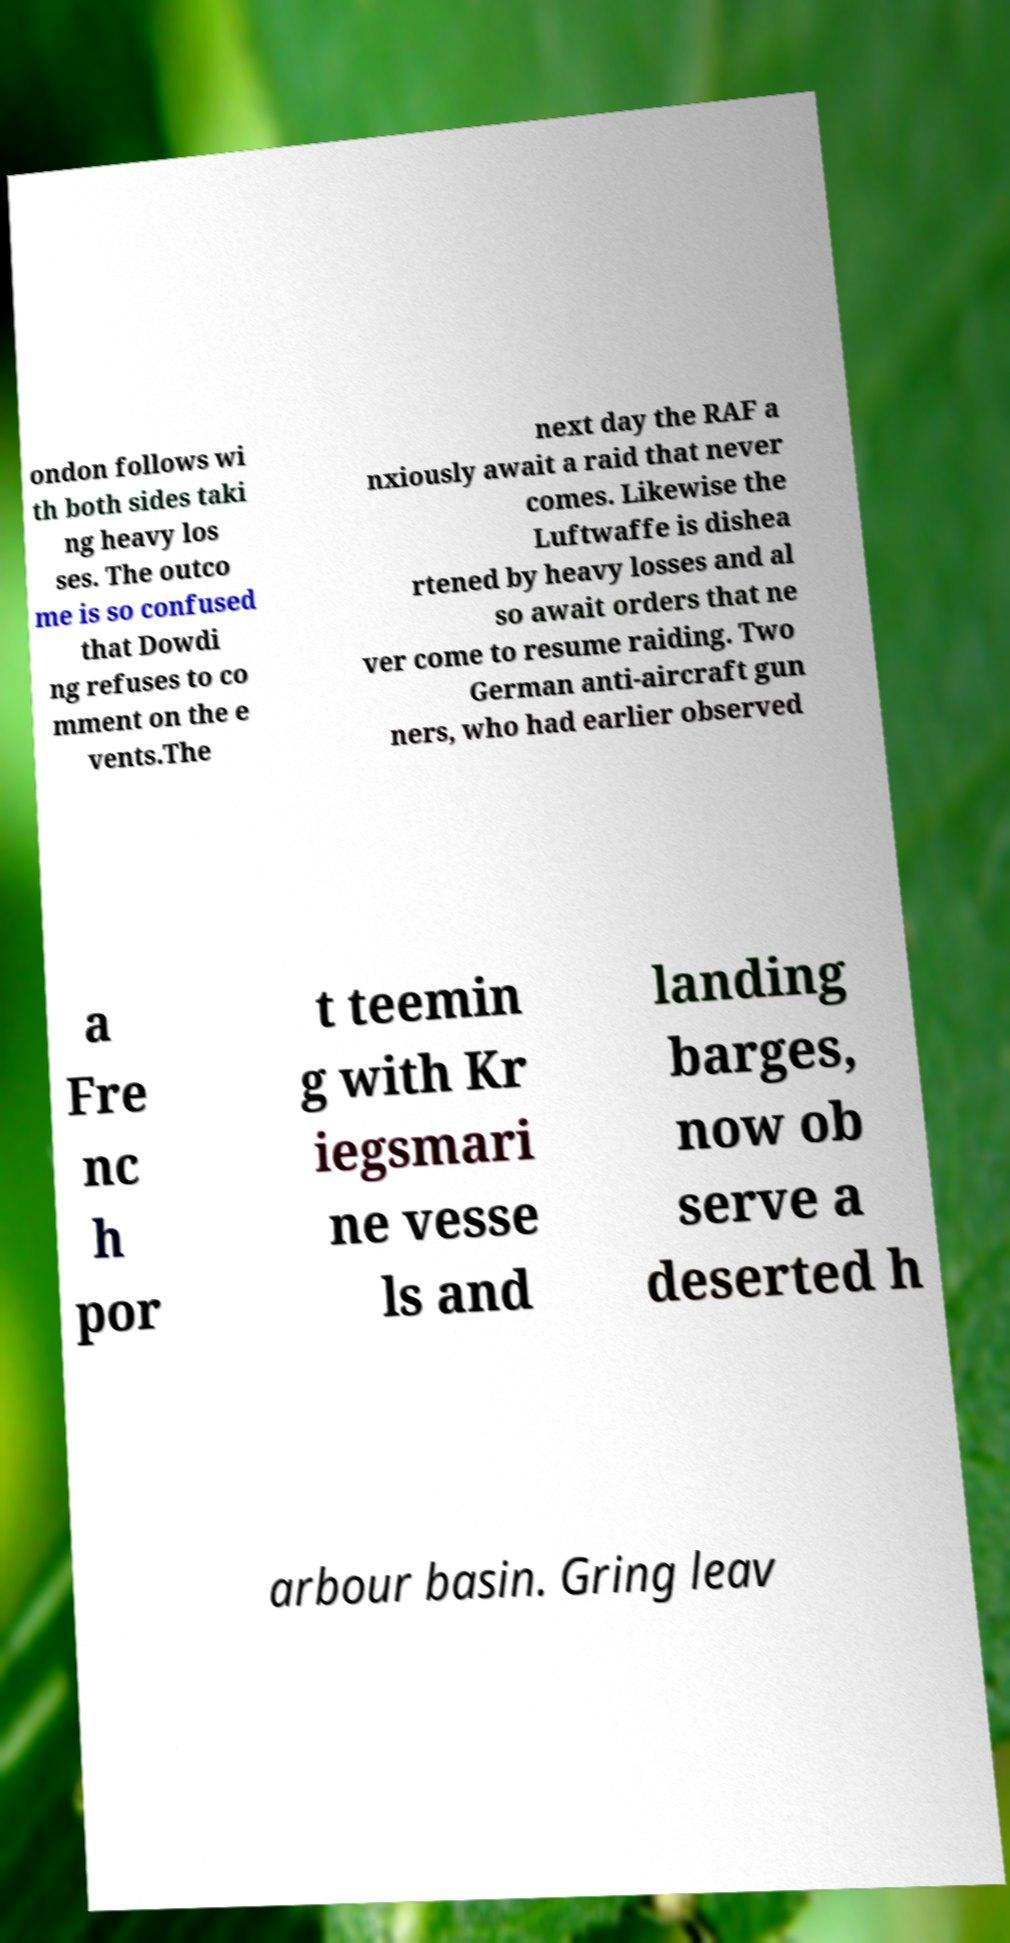I need the written content from this picture converted into text. Can you do that? ondon follows wi th both sides taki ng heavy los ses. The outco me is so confused that Dowdi ng refuses to co mment on the e vents.The next day the RAF a nxiously await a raid that never comes. Likewise the Luftwaffe is dishea rtened by heavy losses and al so await orders that ne ver come to resume raiding. Two German anti-aircraft gun ners, who had earlier observed a Fre nc h por t teemin g with Kr iegsmari ne vesse ls and landing barges, now ob serve a deserted h arbour basin. Gring leav 